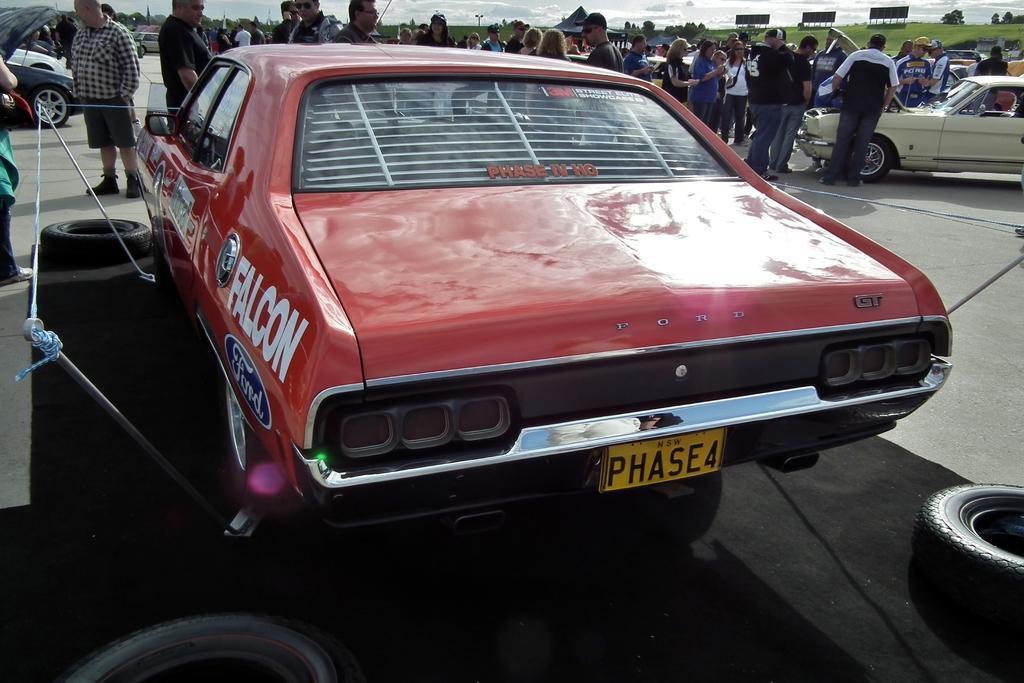Describe this image in one or two sentences. In this image we can see a few people, there are some vehicles, tires, trees, grass, boards, poles and in the background, we can see the sky with clouds. 